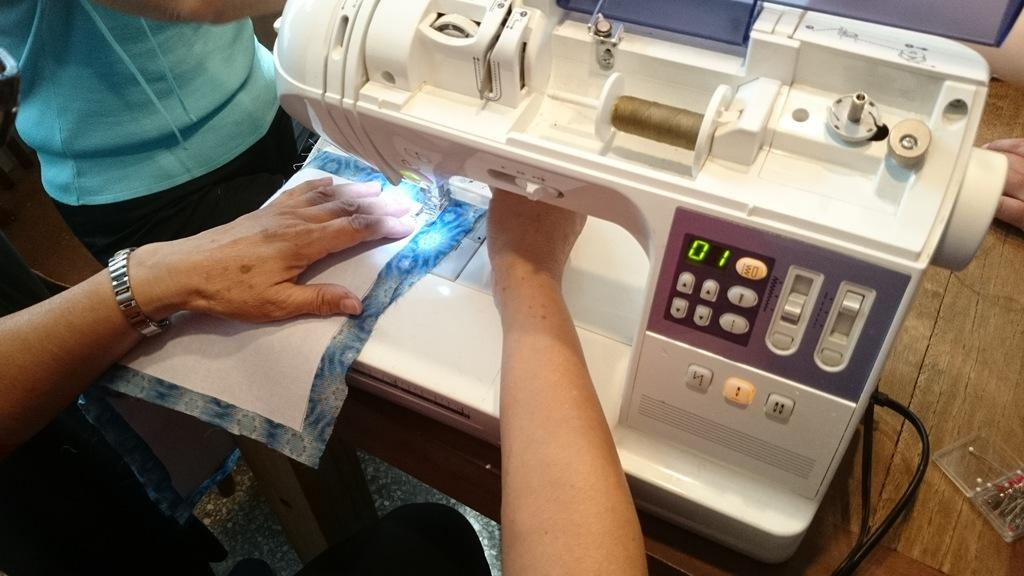How many people are in the image? There are two people in the image. What type of material can be seen in the image? There is cloth visible in the image. What piece of furniture is present in the image? There is a table in the image. What is the purpose of the machine on the table? A sewing machine is present on the table, which is used for sewing. What type of advertisement can be seen on the cloth in the image? There is no advertisement visible on the cloth in the image. 